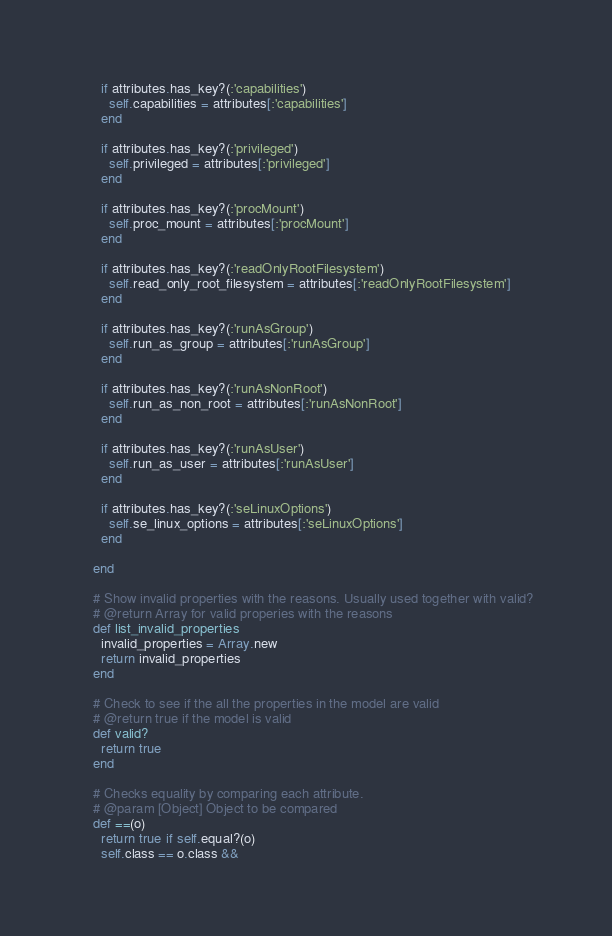Convert code to text. <code><loc_0><loc_0><loc_500><loc_500><_Ruby_>      if attributes.has_key?(:'capabilities')
        self.capabilities = attributes[:'capabilities']
      end

      if attributes.has_key?(:'privileged')
        self.privileged = attributes[:'privileged']
      end

      if attributes.has_key?(:'procMount')
        self.proc_mount = attributes[:'procMount']
      end

      if attributes.has_key?(:'readOnlyRootFilesystem')
        self.read_only_root_filesystem = attributes[:'readOnlyRootFilesystem']
      end

      if attributes.has_key?(:'runAsGroup')
        self.run_as_group = attributes[:'runAsGroup']
      end

      if attributes.has_key?(:'runAsNonRoot')
        self.run_as_non_root = attributes[:'runAsNonRoot']
      end

      if attributes.has_key?(:'runAsUser')
        self.run_as_user = attributes[:'runAsUser']
      end

      if attributes.has_key?(:'seLinuxOptions')
        self.se_linux_options = attributes[:'seLinuxOptions']
      end

    end

    # Show invalid properties with the reasons. Usually used together with valid?
    # @return Array for valid properies with the reasons
    def list_invalid_properties
      invalid_properties = Array.new
      return invalid_properties
    end

    # Check to see if the all the properties in the model are valid
    # @return true if the model is valid
    def valid?
      return true
    end

    # Checks equality by comparing each attribute.
    # @param [Object] Object to be compared
    def ==(o)
      return true if self.equal?(o)
      self.class == o.class &&</code> 